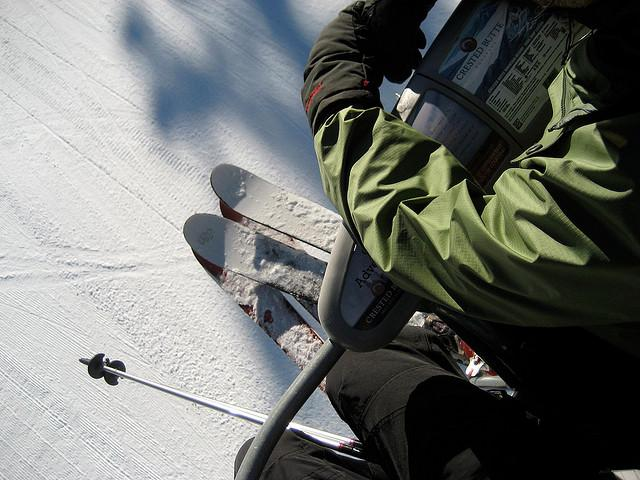What is the person near? Please explain your reasoning. ski poles. There are poles by the person. 